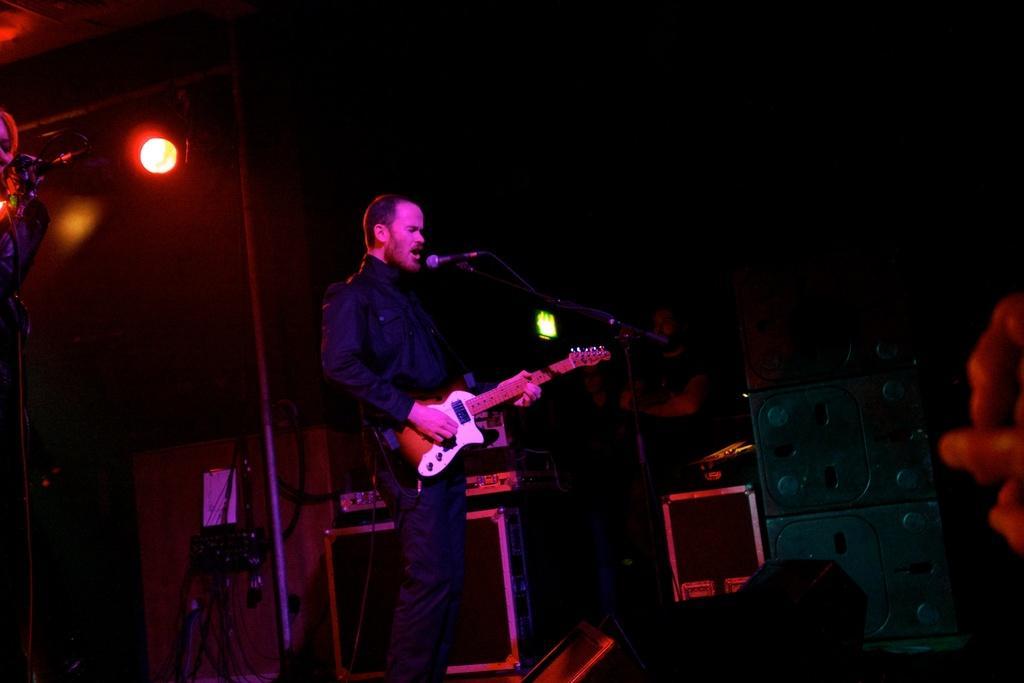Can you describe this image briefly? A man is standing and playing guitar and also singing on microphone,behind him there are lights, musical instruments and few people. 